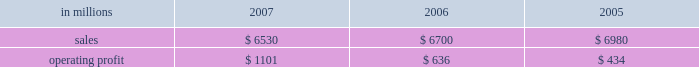Customer demand .
This compared with 555000 tons of total downtime in 2006 of which 150000 tons related to lack-of-orders .
Printing papers in millions 2007 2006 2005 .
North american printing papers net sales in 2007 were $ 3.5 billion compared with $ 4.4 billion in 2006 ( $ 3.5 billion excluding the coated and super- calendered papers business ) and $ 4.8 billion in 2005 ( $ 3.2 billion excluding the coated and super- calendered papers business ) .
Sales volumes decreased in 2007 versus 2006 partially due to reduced production capacity resulting from the conversion of the paper machine at the pensacola mill to the production of lightweight linerboard for our industrial packaging segment .
Average sales price realizations increased significantly , reflecting benefits from price increases announced throughout 2007 .
Lack-of-order downtime declined to 27000 tons in 2007 from 40000 tons in 2006 .
Operating earnings of $ 537 million in 2007 increased from $ 482 million in 2006 ( $ 407 million excluding the coated and supercalendered papers business ) and $ 175 million in 2005 ( $ 74 million excluding the coated and supercalendered papers business ) .
The benefits from improved average sales price realizations more than offset the effects of higher input costs for wood , energy , and freight .
Mill operations were favorable compared with the prior year due to current-year improvements in machine performance and energy conservation efforts .
Sales volumes for the first quarter of 2008 are expected to increase slightly , and the mix of prod- ucts sold to improve .
Demand for printing papers in north america was steady as the quarter began .
Price increases for cut-size paper and roll stock have been announced that are expected to be effective principally late in the first quarter .
Planned mill maintenance outage costs should be about the same as in the fourth quarter ; however , raw material costs are expected to continue to increase , primarily for wood and energy .
Brazil ian papers net sales for 2007 of $ 850 mil- lion were higher than the $ 495 million in 2006 and the $ 465 million in 2005 .
Compared with 2006 , aver- age sales price realizations improved reflecting price increases for uncoated freesheet paper realized dur- ing the second half of 2006 and the first half of 2007 .
Excluding the impact of the luiz antonio acquisition , sales volumes increased primarily for cut size and offset paper .
Operating profits for 2007 of $ 246 mil- lion were up from $ 122 million in 2006 and $ 134 mil- lion in 2005 as the benefits from higher sales prices and favorable manufacturing costs were only parti- ally offset by higher input costs .
Contributions from the luiz antonio acquisition increased net sales by approximately $ 350 million and earnings by approx- imately $ 80 million in 2007 .
Entering 2008 , sales volumes for uncoated freesheet paper and pulp should be seasonally lower .
Average price realizations should be essentially flat , but mar- gins are expected to reflect a less favorable product mix .
Energy costs , primarily for hydroelectric power , are expected to increase significantly reflecting a lack of rainfall in brazil in the latter part of 2007 .
European papers net sales in 2007 were $ 1.5 bil- lion compared with $ 1.3 billion in 2006 and $ 1.2 bil- lion in 2005 .
Sales volumes in 2007 were higher than in 2006 at our eastern european mills reflecting stronger market demand and improved efficiencies , but lower in western europe reflecting the closure of the marasquel mill in 2006 .
Average sales price real- izations increased significantly in 2007 in both east- ern and western european markets .
Operating profits of $ 214 million in 2007 increased from a loss of $ 16 million in 2006 and earnings of $ 88 million in 2005 .
The loss in 2006 reflects the impact of a $ 128 million impairment charge to reduce the carrying value of the fixed assets at the saillat , france mill .
Excluding this charge , the improvement in 2007 compared with 2006 reflects the contribution from higher net sales , partially offset by higher input costs for wood , energy and freight .
Looking ahead to the first quarter of 2008 , sales volumes are expected to be stable in western europe , but seasonally weaker in eastern europe and russia .
Average price realizations are expected to remain about flat .
Wood costs are expected to increase , especially in russia due to strong demand ahead of tariff increases , and energy costs are anticipated to be seasonally higher .
Asian printing papers net sales were approx- imately $ 20 million in 2007 , compared with $ 15 mil- lion in 2006 and $ 10 million in 2005 .
Operating earnings increased slightly in 2007 , but were close to breakeven in all periods .
U.s .
Market pulp sales in 2007 totaled $ 655 mil- lion compared with $ 510 million and $ 525 million in 2006 and 2005 , respectively .
Sales volumes in 2007 were up from 2006 levels , primarily for paper and .
What was the percentage change in the net sales in asian papers from 2006 to 2007? 
Computations: ((20 - 15) / 15)
Answer: 0.33333. 